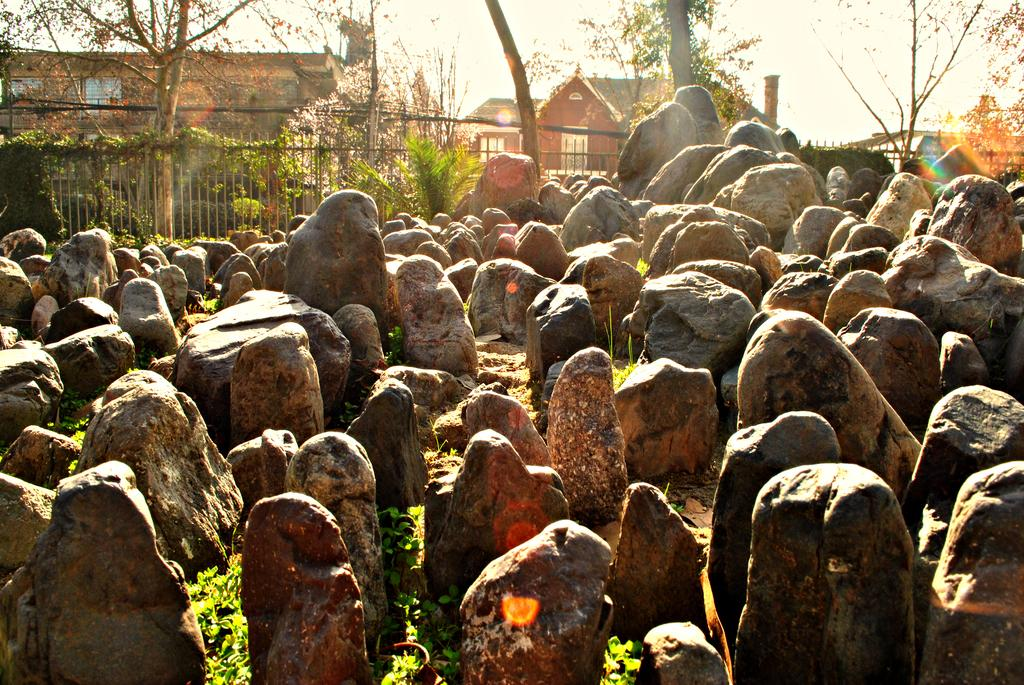What type of natural elements can be seen in the image? There are rocks in the image. What man-made structure is present in the image? There is a fence in the image. What type of vegetation is visible in the image? There are trees in the image. What type of human-made structures can be seen in the image? There are buildings in the image. What type of sweater is the tree wearing in the image? There are no sweaters present in the image, as trees are not capable of wearing clothing. 